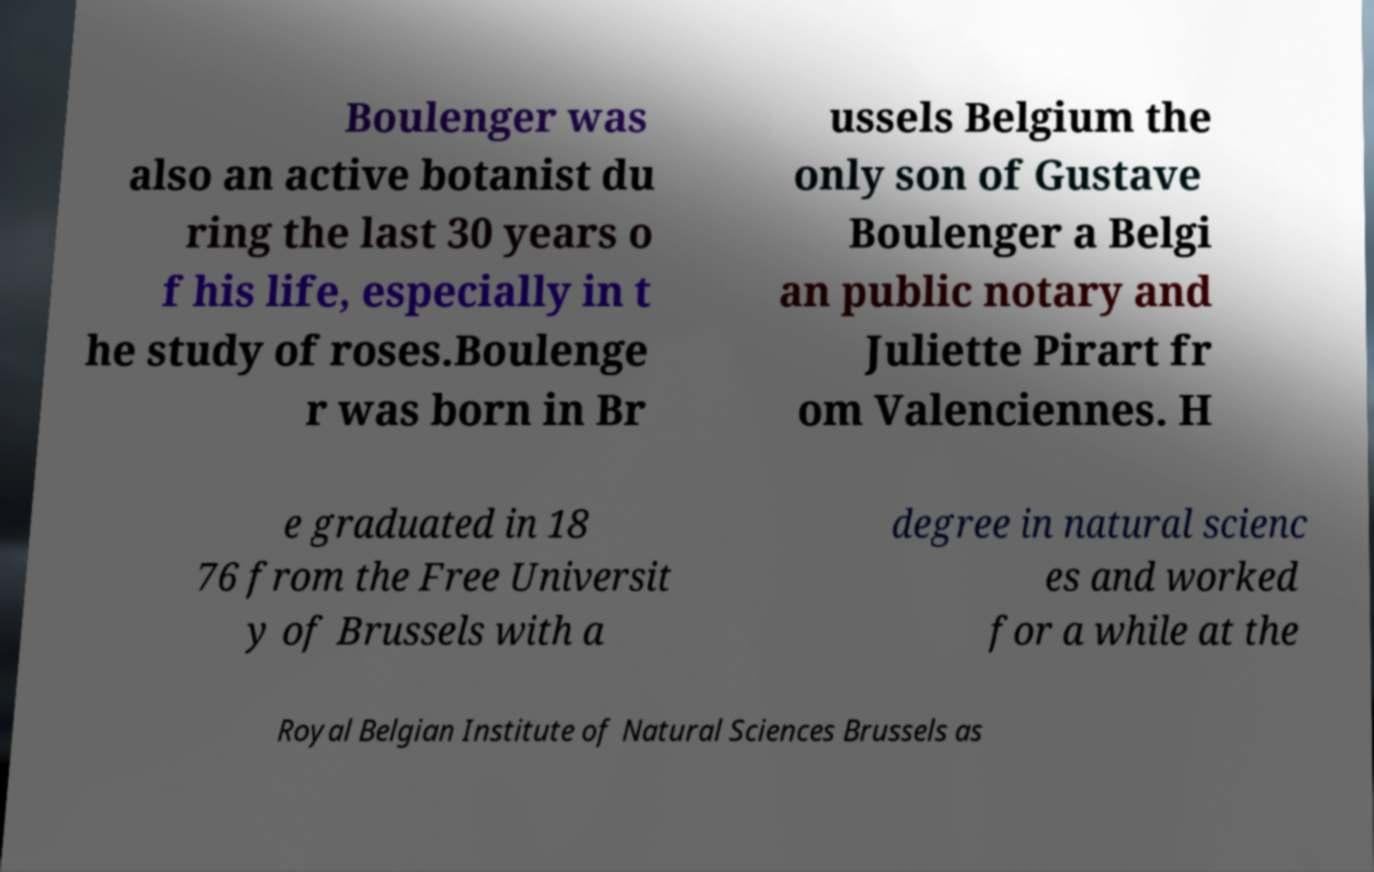Could you assist in decoding the text presented in this image and type it out clearly? Boulenger was also an active botanist du ring the last 30 years o f his life, especially in t he study of roses.Boulenge r was born in Br ussels Belgium the only son of Gustave Boulenger a Belgi an public notary and Juliette Pirart fr om Valenciennes. H e graduated in 18 76 from the Free Universit y of Brussels with a degree in natural scienc es and worked for a while at the Royal Belgian Institute of Natural Sciences Brussels as 